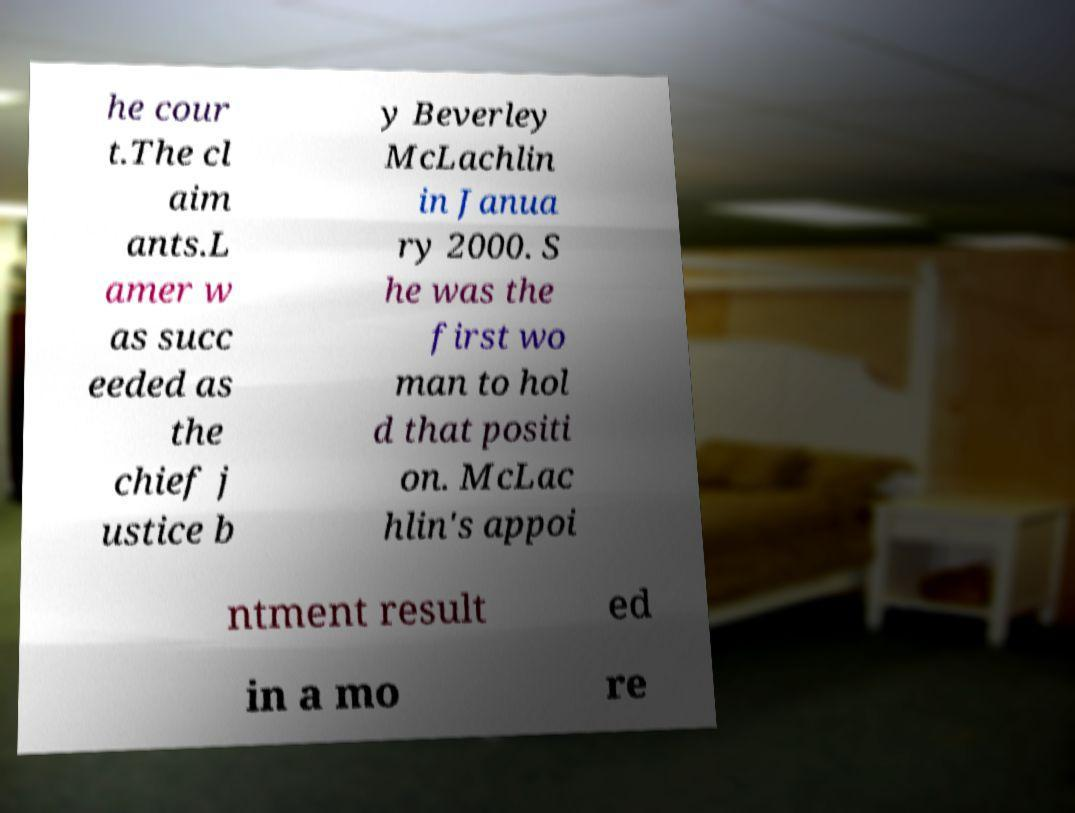Please read and relay the text visible in this image. What does it say? he cour t.The cl aim ants.L amer w as succ eeded as the chief j ustice b y Beverley McLachlin in Janua ry 2000. S he was the first wo man to hol d that positi on. McLac hlin's appoi ntment result ed in a mo re 